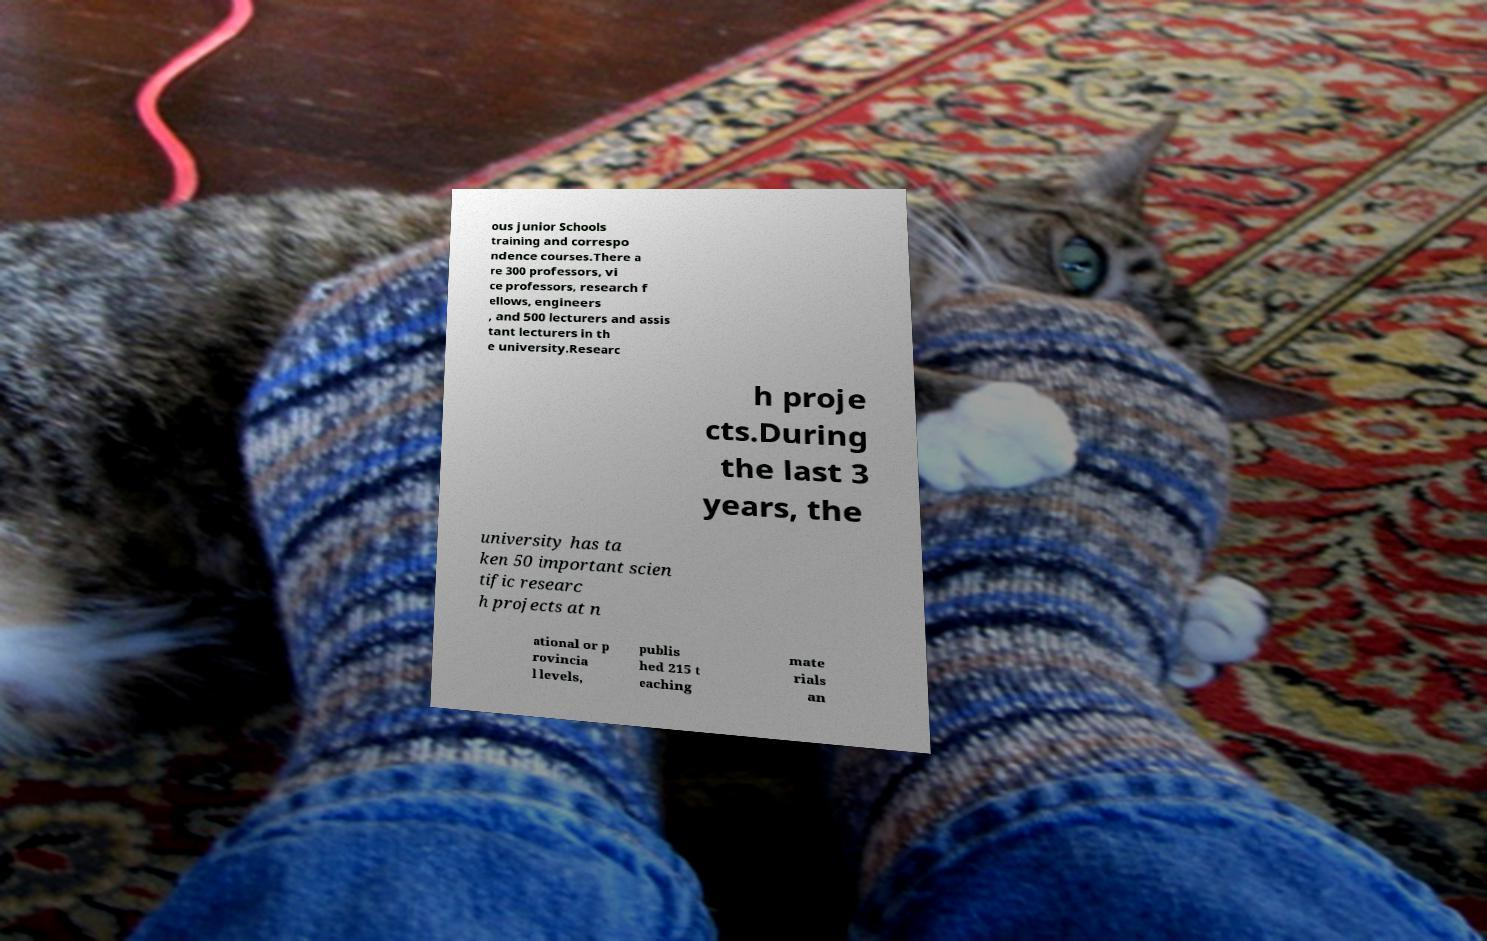There's text embedded in this image that I need extracted. Can you transcribe it verbatim? ous junior Schools training and correspo ndence courses.There a re 300 professors, vi ce professors, research f ellows, engineers , and 500 lecturers and assis tant lecturers in th e university.Researc h proje cts.During the last 3 years, the university has ta ken 50 important scien tific researc h projects at n ational or p rovincia l levels, publis hed 215 t eaching mate rials an 